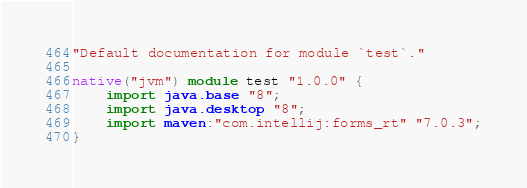Convert code to text. <code><loc_0><loc_0><loc_500><loc_500><_Ceylon_>"Default documentation for module `test`."

native("jvm") module test "1.0.0" {
    import java.base "8";
    import java.desktop "8";
    import maven:"com.intellij:forms_rt" "7.0.3";
}
</code> 